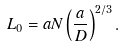Convert formula to latex. <formula><loc_0><loc_0><loc_500><loc_500>L _ { 0 } = a N \left ( \frac { a } { D } \right ) ^ { 2 / 3 } .</formula> 